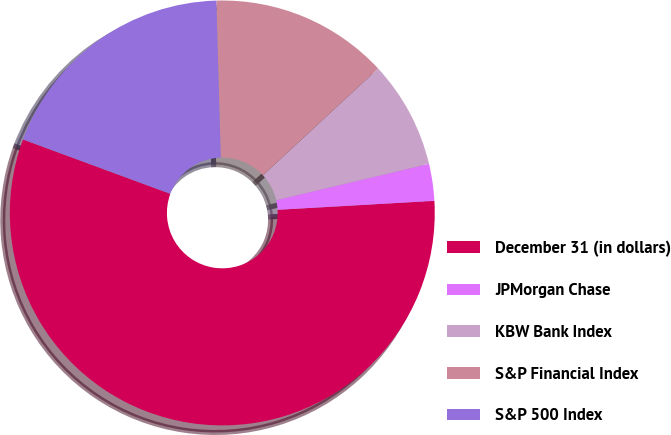Convert chart to OTSL. <chart><loc_0><loc_0><loc_500><loc_500><pie_chart><fcel>December 31 (in dollars)<fcel>JPMorgan Chase<fcel>KBW Bank Index<fcel>S&P Financial Index<fcel>S&P 500 Index<nl><fcel>56.53%<fcel>2.81%<fcel>8.18%<fcel>13.55%<fcel>18.93%<nl></chart> 